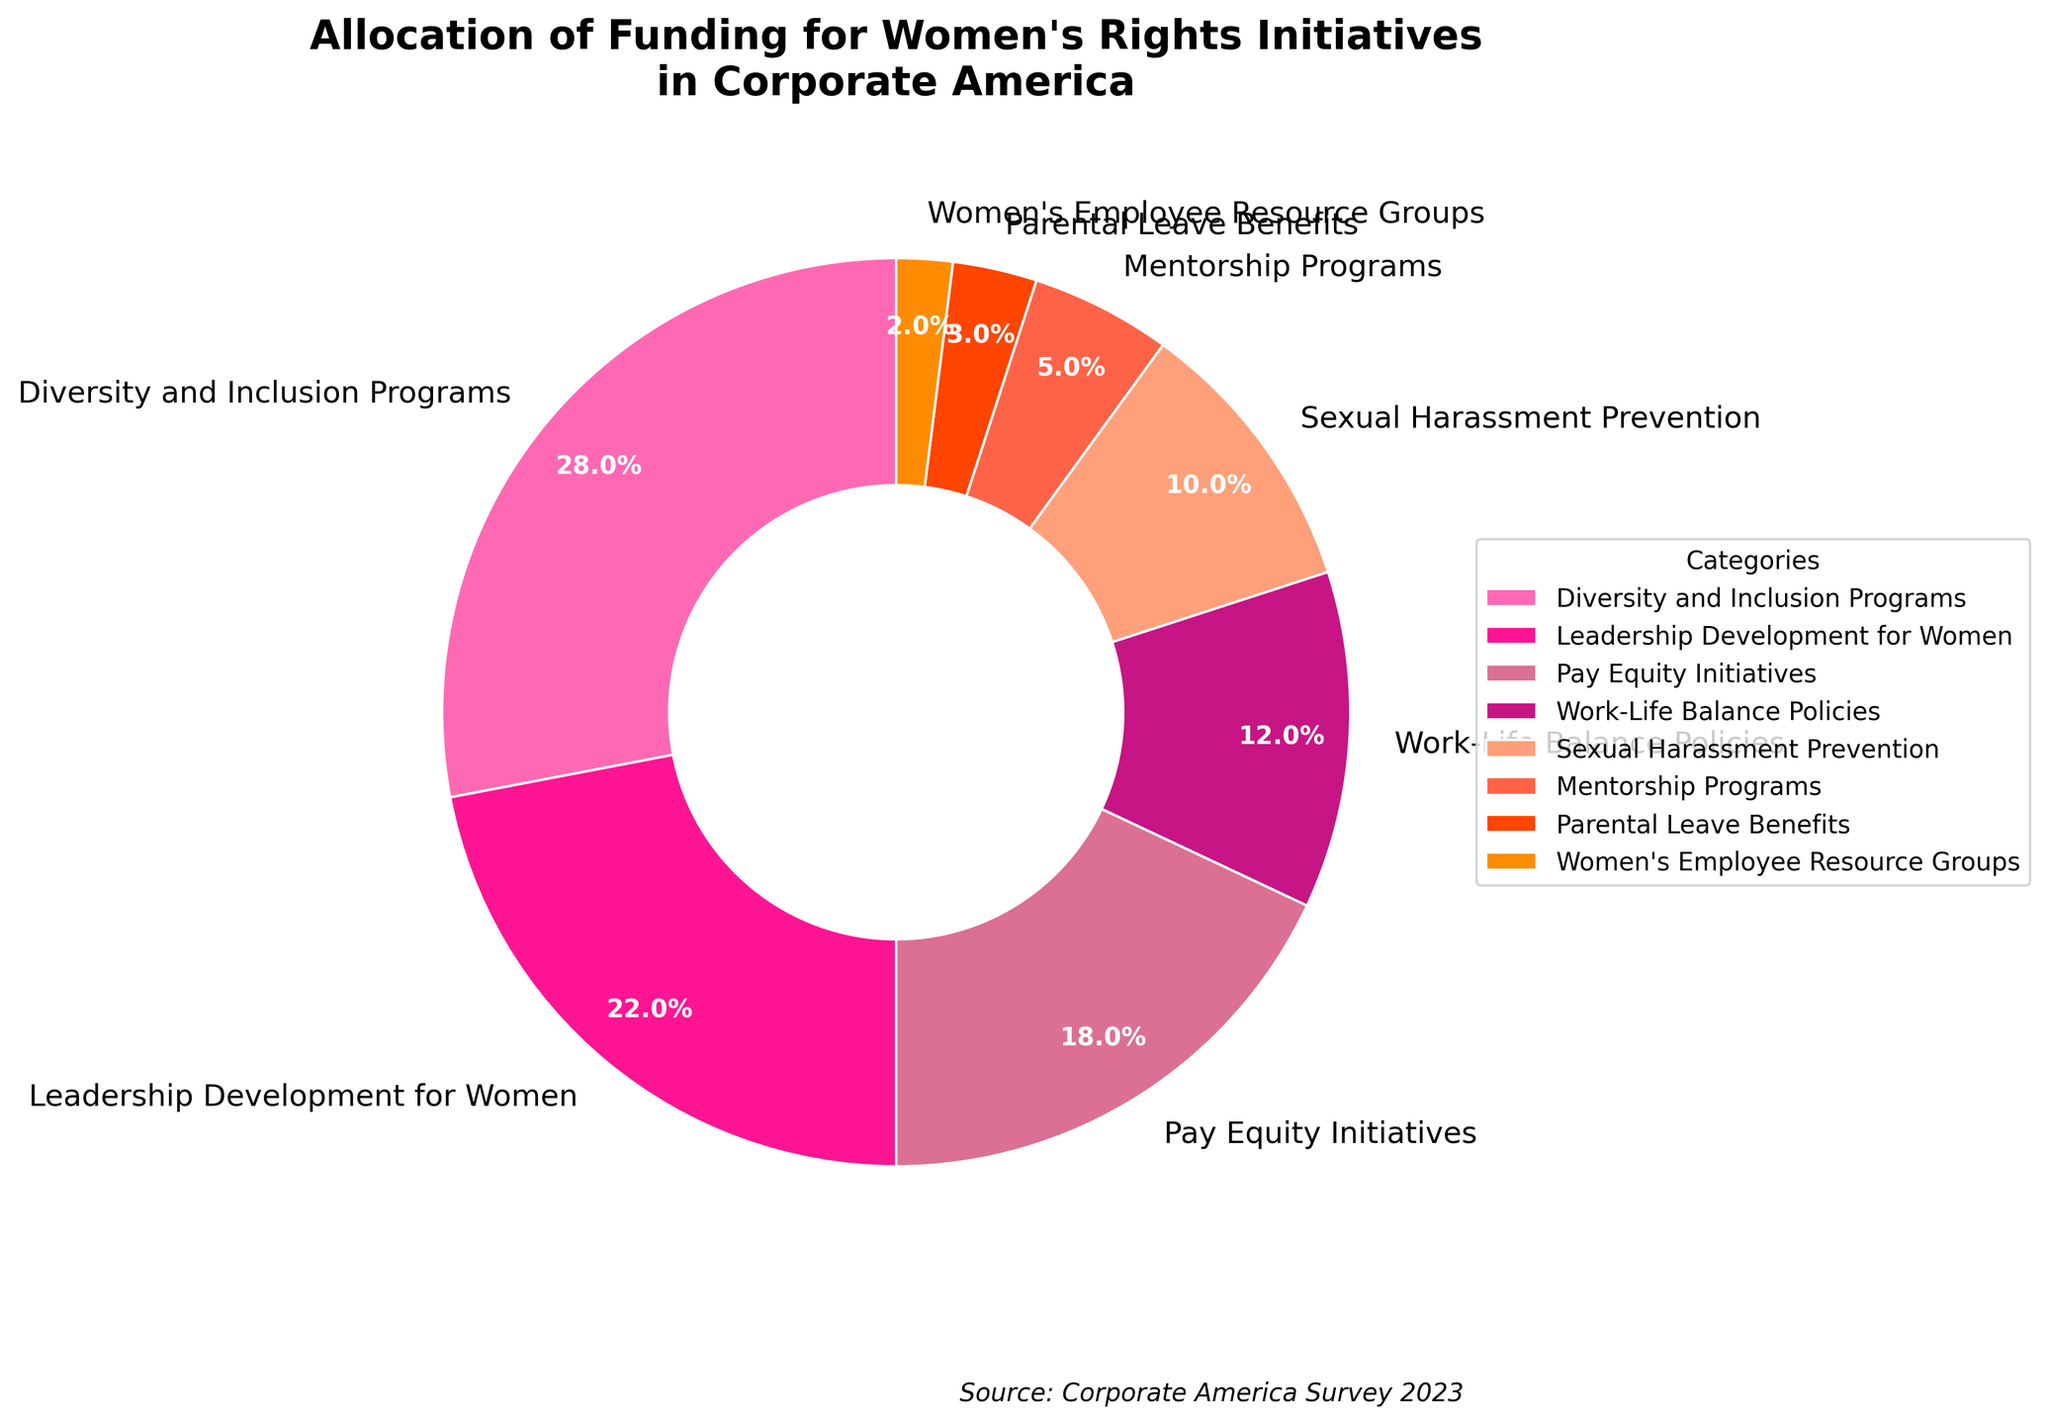Which category receives the highest percentage of funding? Locate the category with the largest portion of the pie chart. "Diversity and Inclusion Programs" has the highest percentage at 28%
Answer: Diversity and Inclusion Programs Which two categories have the smallest funding percentages? Identify the smallest portions of the pie chart. "Women's Employee Resource Groups" at 2% and "Parental Leave Benefits" at 3% have the smallest funding percentages
Answer: Women's Employee Resource Groups and Parental Leave Benefits Adding the percentages of Pay Equity Initiatives and Sexual Harassment Prevention, what is the total? Sum up the percentages of "Pay Equity Initiatives" and "Sexual Harassment Prevention". 18% + 10% = 28%
Answer: 28% Is the funding for Leadership Development for Women greater than the funding for Work-Life Balance Policies? Compare the percentages: "Leadership Development for Women" has 22% and "Work-Life Balance Policies" has 12%. 22% is greater than 12%
Answer: Yes What percentage more funding do Leadership Development for Women initiatives receive compared to Mentorship Programs? Subtract the percentage of "Mentorship Programs" from "Leadership Development for Women". 22% - 5% = 17%
Answer: 17% What is the combined funding percentage for Diversity and Inclusion Programs and Leadership Development for Women initiatives? Add the percentages of "Diversity and Inclusion Programs" and "Leadership Development for Women". 28% + 22% = 50%
Answer: 50% How does the funding for Work-Life Balance Policies compare to Pay Equity Initiatives? Compare the percentages: "Work-Life Balance Policies" have 12% and "Pay Equity Initiatives" have 18%. 12% is less than 18%
Answer: Less If the funding for Sexual Harassment Prevention and Mentorship Programs were combined, would it be higher than the funding for Pay Equity Initiatives? Add the percentages of "Sexual Harassment Prevention" and "Mentorship Programs" and compare to "Pay Equity Initiatives". 10% + 5% = 15%, which is less than 18%
Answer: No 